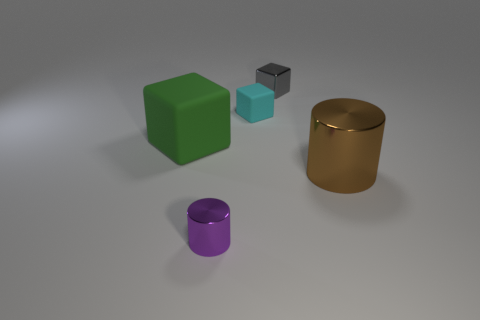What color is the tiny shiny object that is behind the rubber thing left of the purple object? The tiny shiny object situated behind the rubber-like material, which is to the left of the purple cylindrical object, appears to be silver in color with a reflective surface. 